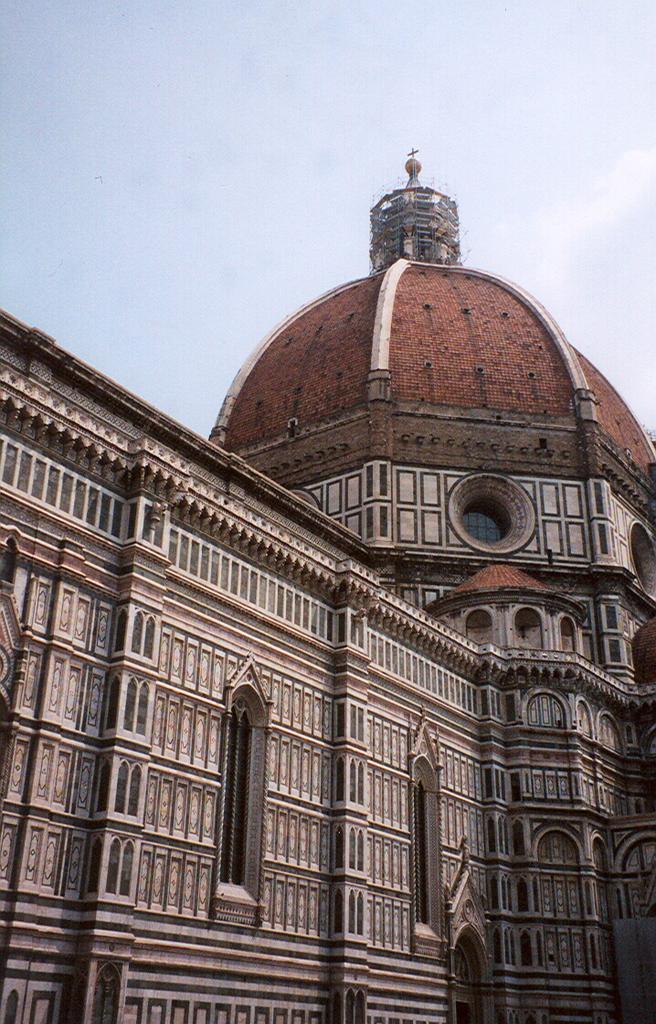Please provide a concise description of this image. In this image I can see a building in the front and in the background I can see the sky. 